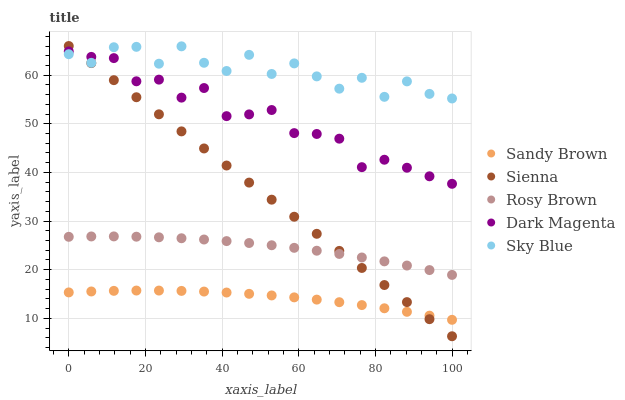Does Sandy Brown have the minimum area under the curve?
Answer yes or no. Yes. Does Sky Blue have the maximum area under the curve?
Answer yes or no. Yes. Does Rosy Brown have the minimum area under the curve?
Answer yes or no. No. Does Rosy Brown have the maximum area under the curve?
Answer yes or no. No. Is Sienna the smoothest?
Answer yes or no. Yes. Is Sky Blue the roughest?
Answer yes or no. Yes. Is Rosy Brown the smoothest?
Answer yes or no. No. Is Rosy Brown the roughest?
Answer yes or no. No. Does Sienna have the lowest value?
Answer yes or no. Yes. Does Rosy Brown have the lowest value?
Answer yes or no. No. Does Sienna have the highest value?
Answer yes or no. Yes. Does Sky Blue have the highest value?
Answer yes or no. No. Is Sandy Brown less than Sky Blue?
Answer yes or no. Yes. Is Dark Magenta greater than Sandy Brown?
Answer yes or no. Yes. Does Sky Blue intersect Sienna?
Answer yes or no. Yes. Is Sky Blue less than Sienna?
Answer yes or no. No. Is Sky Blue greater than Sienna?
Answer yes or no. No. Does Sandy Brown intersect Sky Blue?
Answer yes or no. No. 